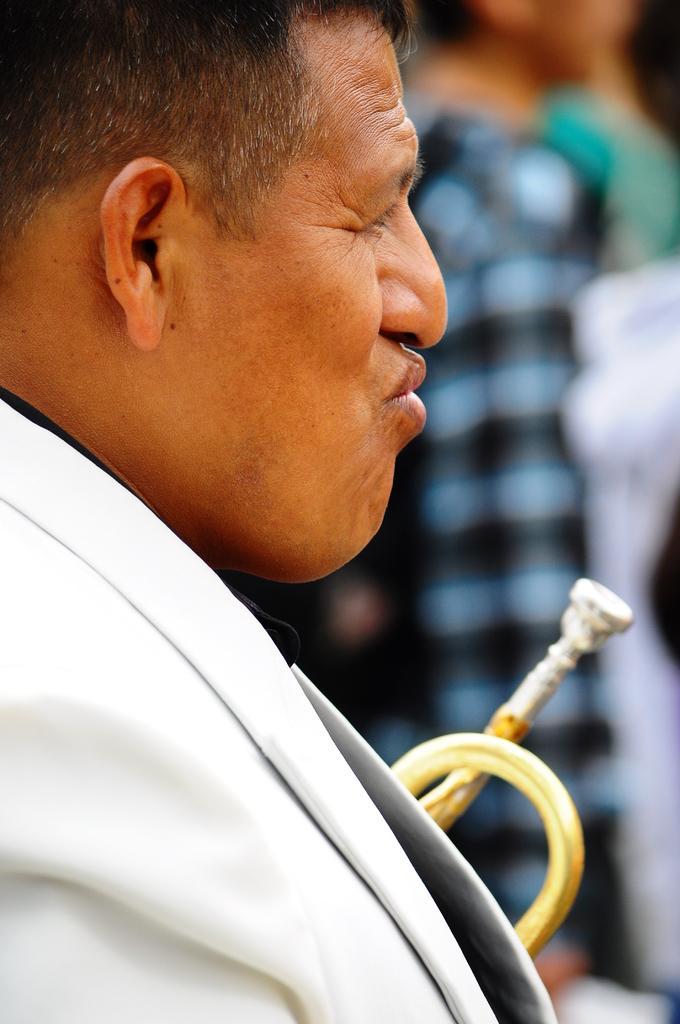Describe this image in one or two sentences. In this image I can see one person is wearing white color dress. Background is blurred. 